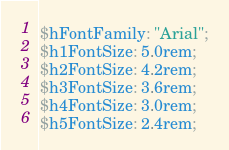Convert code to text. <code><loc_0><loc_0><loc_500><loc_500><_CSS_>$hFontFamily: "Arial";
$h1FontSize: 5.0rem;
$h2FontSize: 4.2rem;
$h3FontSize: 3.6rem;
$h4FontSize: 3.0rem;
$h5FontSize: 2.4rem;
</code> 